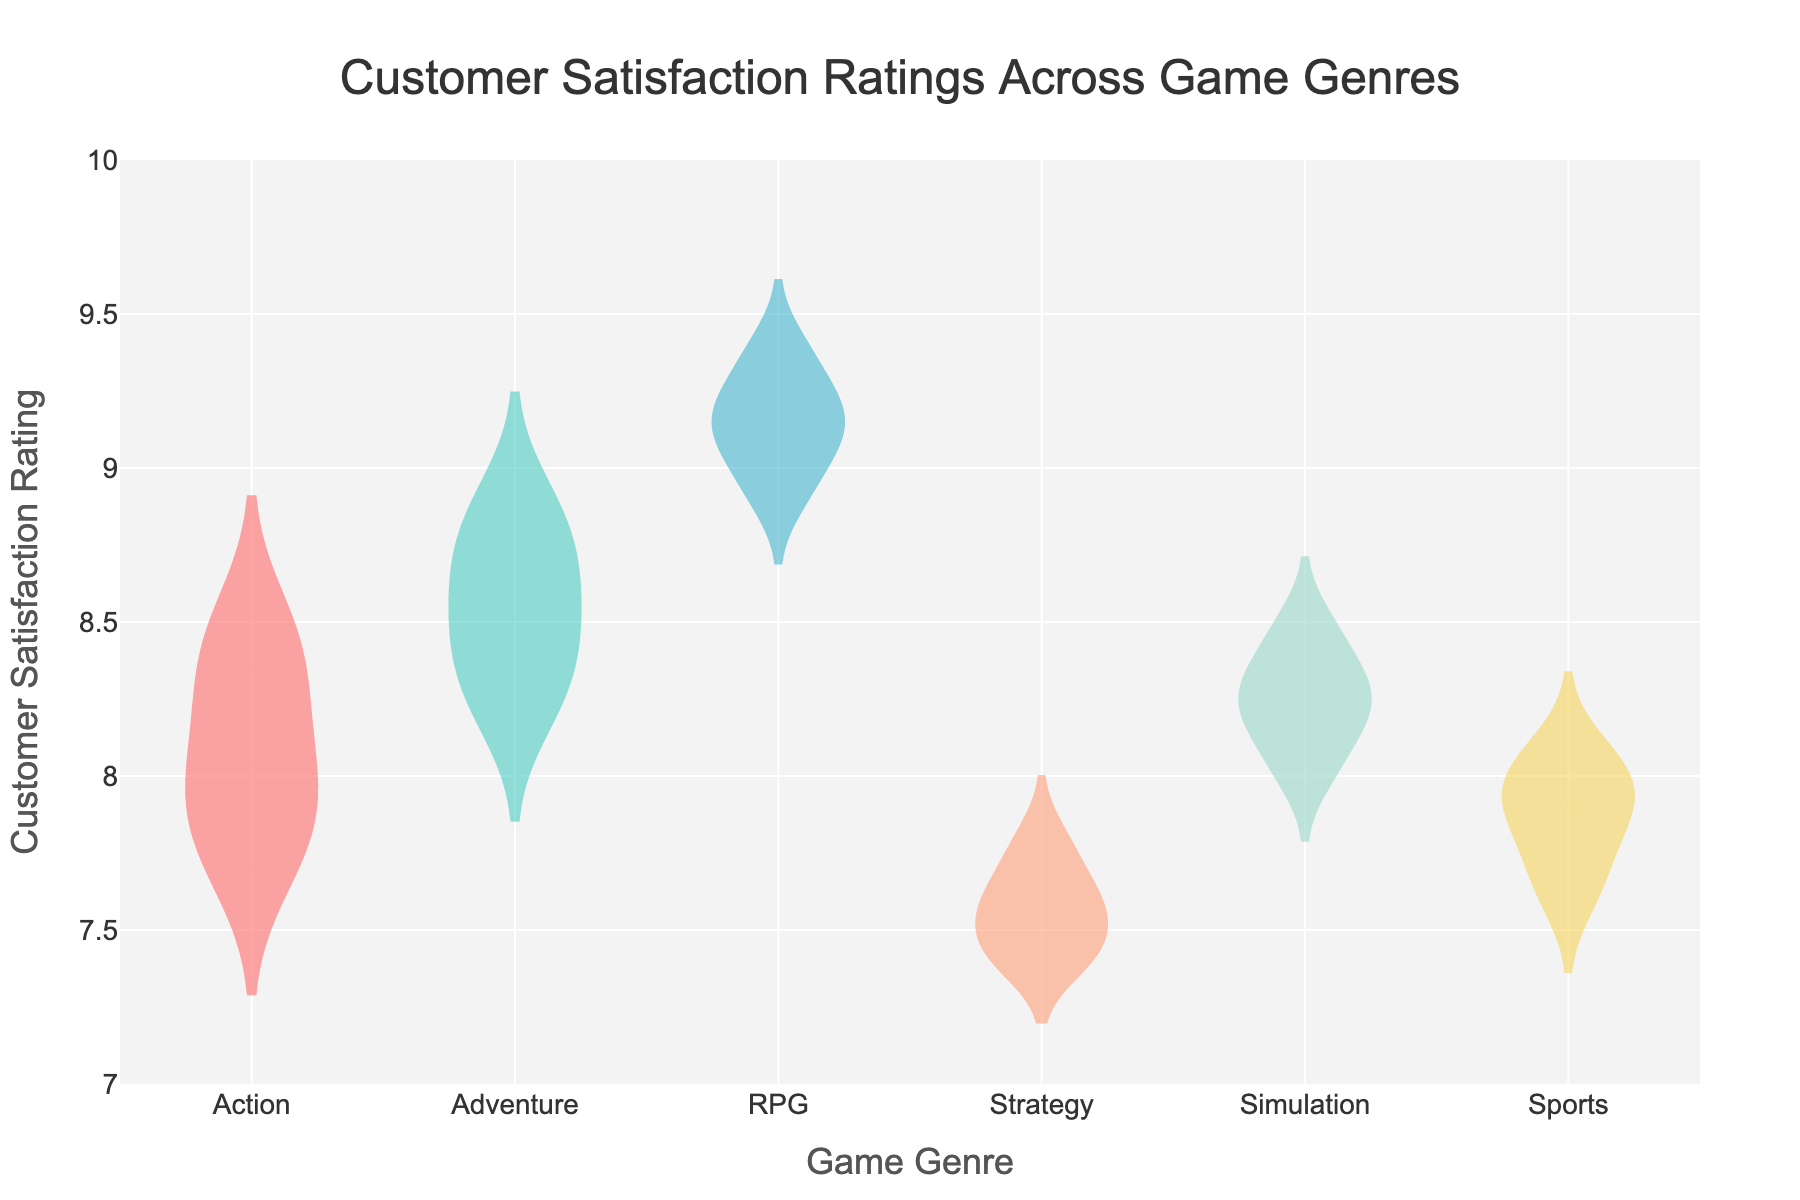How many game genres are compared in the chart? The figure shows the violin plots with box plot overlays for different game genres. By counting the unique violin plots, we can determine the number of genres compared.
Answer: 6 What is the median customer satisfaction rating for RPG games? The box plot within the violin plot for RPG games shows a horizontal line, which represents the median value. This line is observed at approximately 9.2.
Answer: 9.2 Which genre has the highest median customer satisfaction rating? By comparing the horizontal lines (representing medians) within the box plots for all genres, we can see that RPG has the highest median at approximately 9.2.
Answer: RPG What is the range of customer satisfaction ratings for the Strategy genre? The range is determined by finding the minimum and maximum values within the violin plot for Strategy. The whiskers of the box plot suggest that the Strategy genre ranges from around 7.4 to 7.8.
Answer: 7.4 to 7.8 Is the mean customer satisfaction rating for Action higher than that for Sports? By examining the dashed lines (representing means) within the violin plots for Action and Sports, and comparing their positions, we conclude that the mean for Action (around 8.0) is higher than that for Sports (around 7.8).
Answer: Yes Which genre has the most variability in customer satisfaction ratings? Variability is observed by looking at the width and spread of the violin plots. The RPG genre has a relatively wider and spread-out shape, indicating the highest variability among genres.
Answer: RPG How many individual data points are shown for the Adventure genre? Counting the number of small, distinct points within the violin plot for Adventure, we find there are 8 data points.
Answer: 8 What is the interquartile range (IQR) for the Simulation genre? The IQR is found by subtracting the lower quartile value from the upper quartile value within the box plot for Simulation. The box suggests values between approximately 8.1 and 8.3, so the IQR is 8.3 - 8.1.
Answer: 0.2 Does any genre have customer satisfaction ratings that fall outside the range of 7 to 10? By examining the ranges of the violin plots for each genre, all observed data points fall within the satisfaction rating range of 7 to 10.
Answer: No 